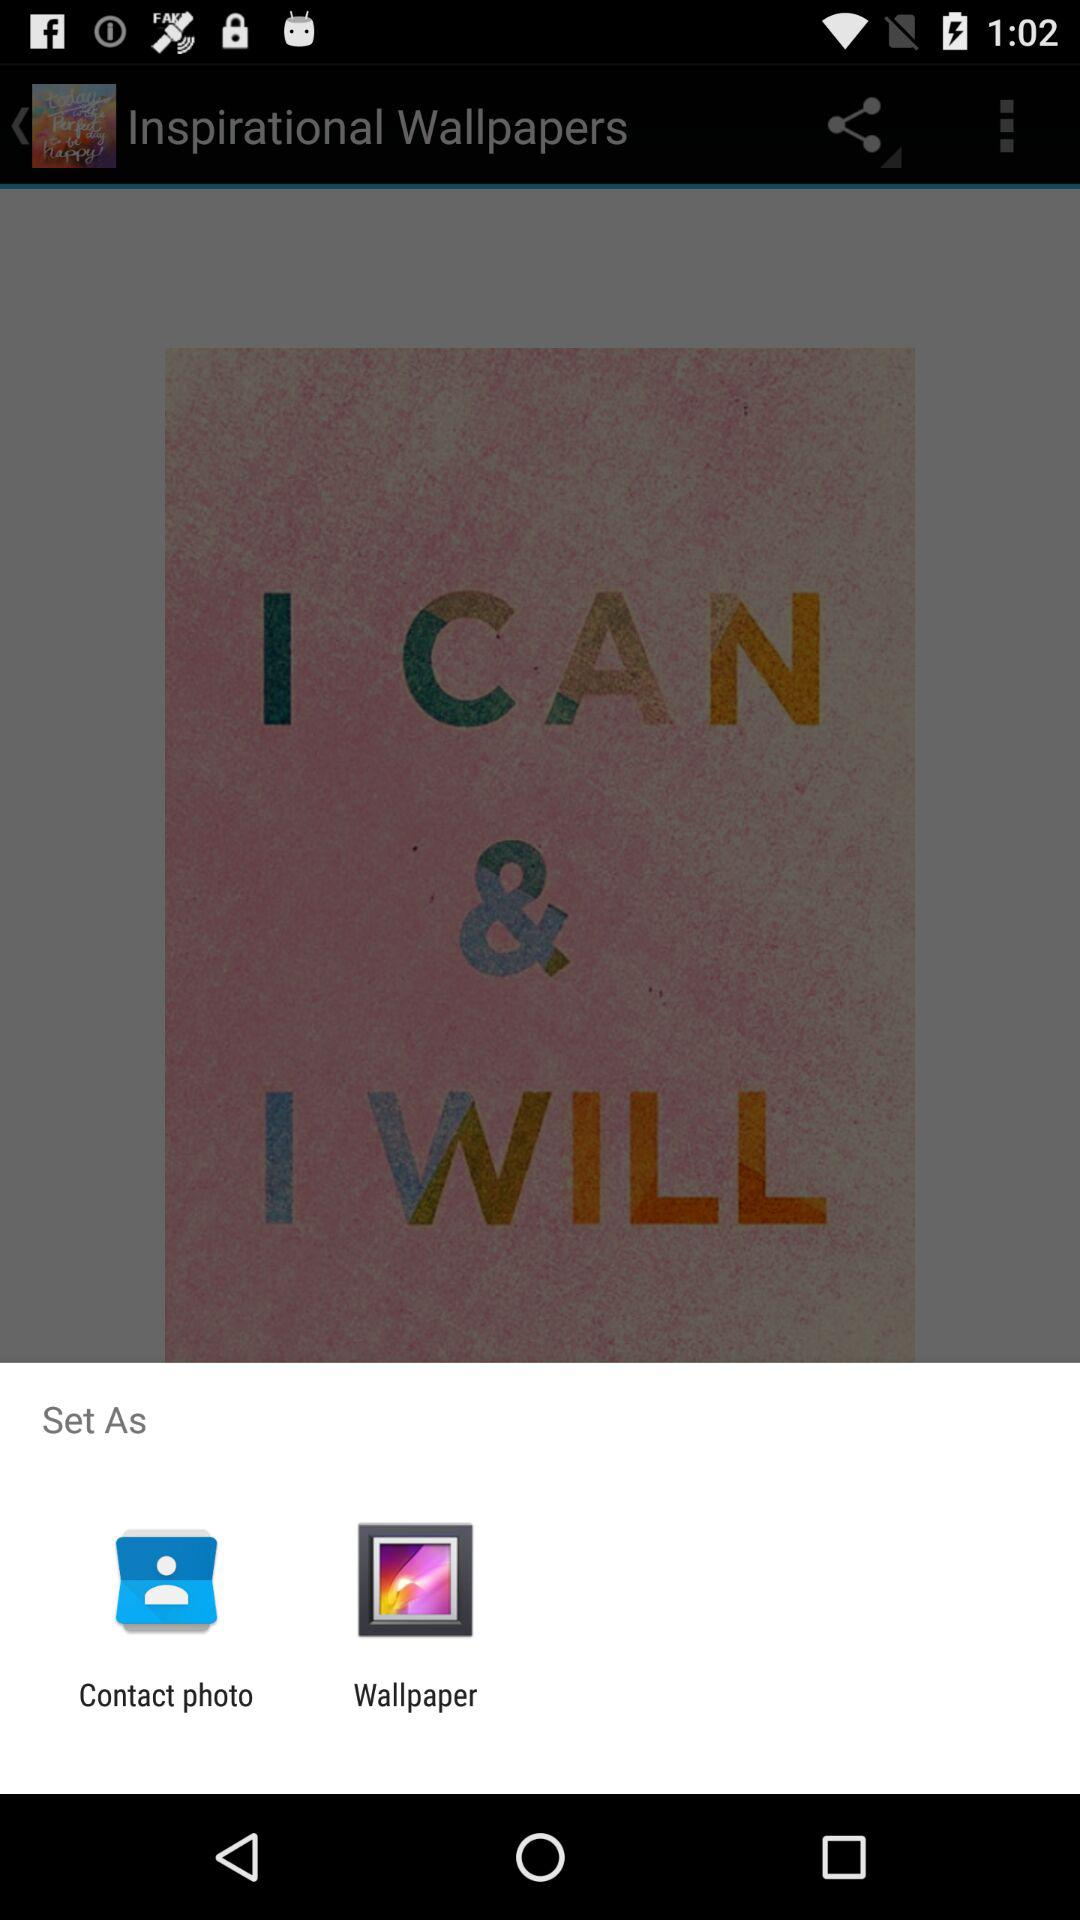In which options can the images be set? The images can be set in the "Contact photo" and "Wallpaper" options. 